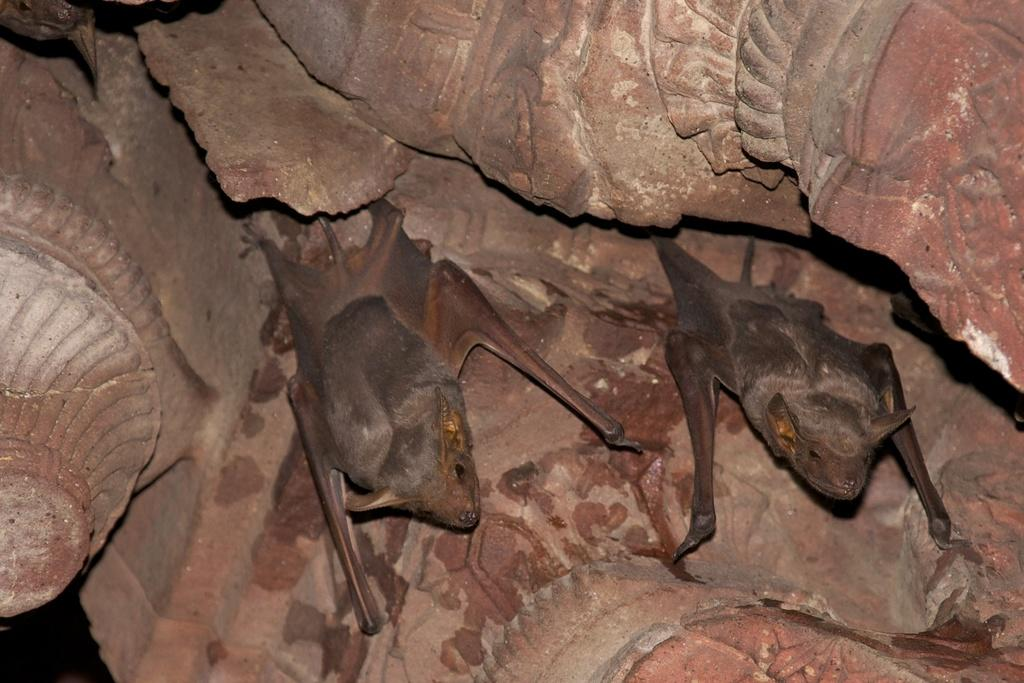What animals are in the foreground of the image? There are two bats in the foreground of the image. Where are the bats located? The bats are on a stone wall. What type of pie is being served in the garden in the image? There is no pie or garden present in the image; it features two bats on a stone wall. Which actor is performing in the image? There is no actor or performance in the image; it features two bats on a stone wall. 